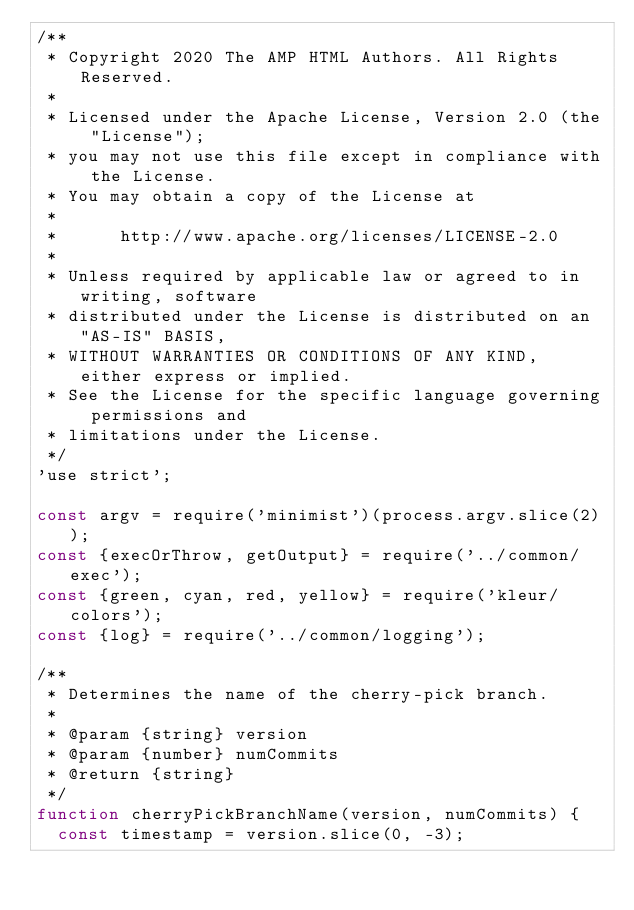<code> <loc_0><loc_0><loc_500><loc_500><_JavaScript_>/**
 * Copyright 2020 The AMP HTML Authors. All Rights Reserved.
 *
 * Licensed under the Apache License, Version 2.0 (the "License");
 * you may not use this file except in compliance with the License.
 * You may obtain a copy of the License at
 *
 *      http://www.apache.org/licenses/LICENSE-2.0
 *
 * Unless required by applicable law or agreed to in writing, software
 * distributed under the License is distributed on an "AS-IS" BASIS,
 * WITHOUT WARRANTIES OR CONDITIONS OF ANY KIND, either express or implied.
 * See the License for the specific language governing permissions and
 * limitations under the License.
 */
'use strict';

const argv = require('minimist')(process.argv.slice(2));
const {execOrThrow, getOutput} = require('../common/exec');
const {green, cyan, red, yellow} = require('kleur/colors');
const {log} = require('../common/logging');

/**
 * Determines the name of the cherry-pick branch.
 *
 * @param {string} version
 * @param {number} numCommits
 * @return {string}
 */
function cherryPickBranchName(version, numCommits) {
  const timestamp = version.slice(0, -3);</code> 